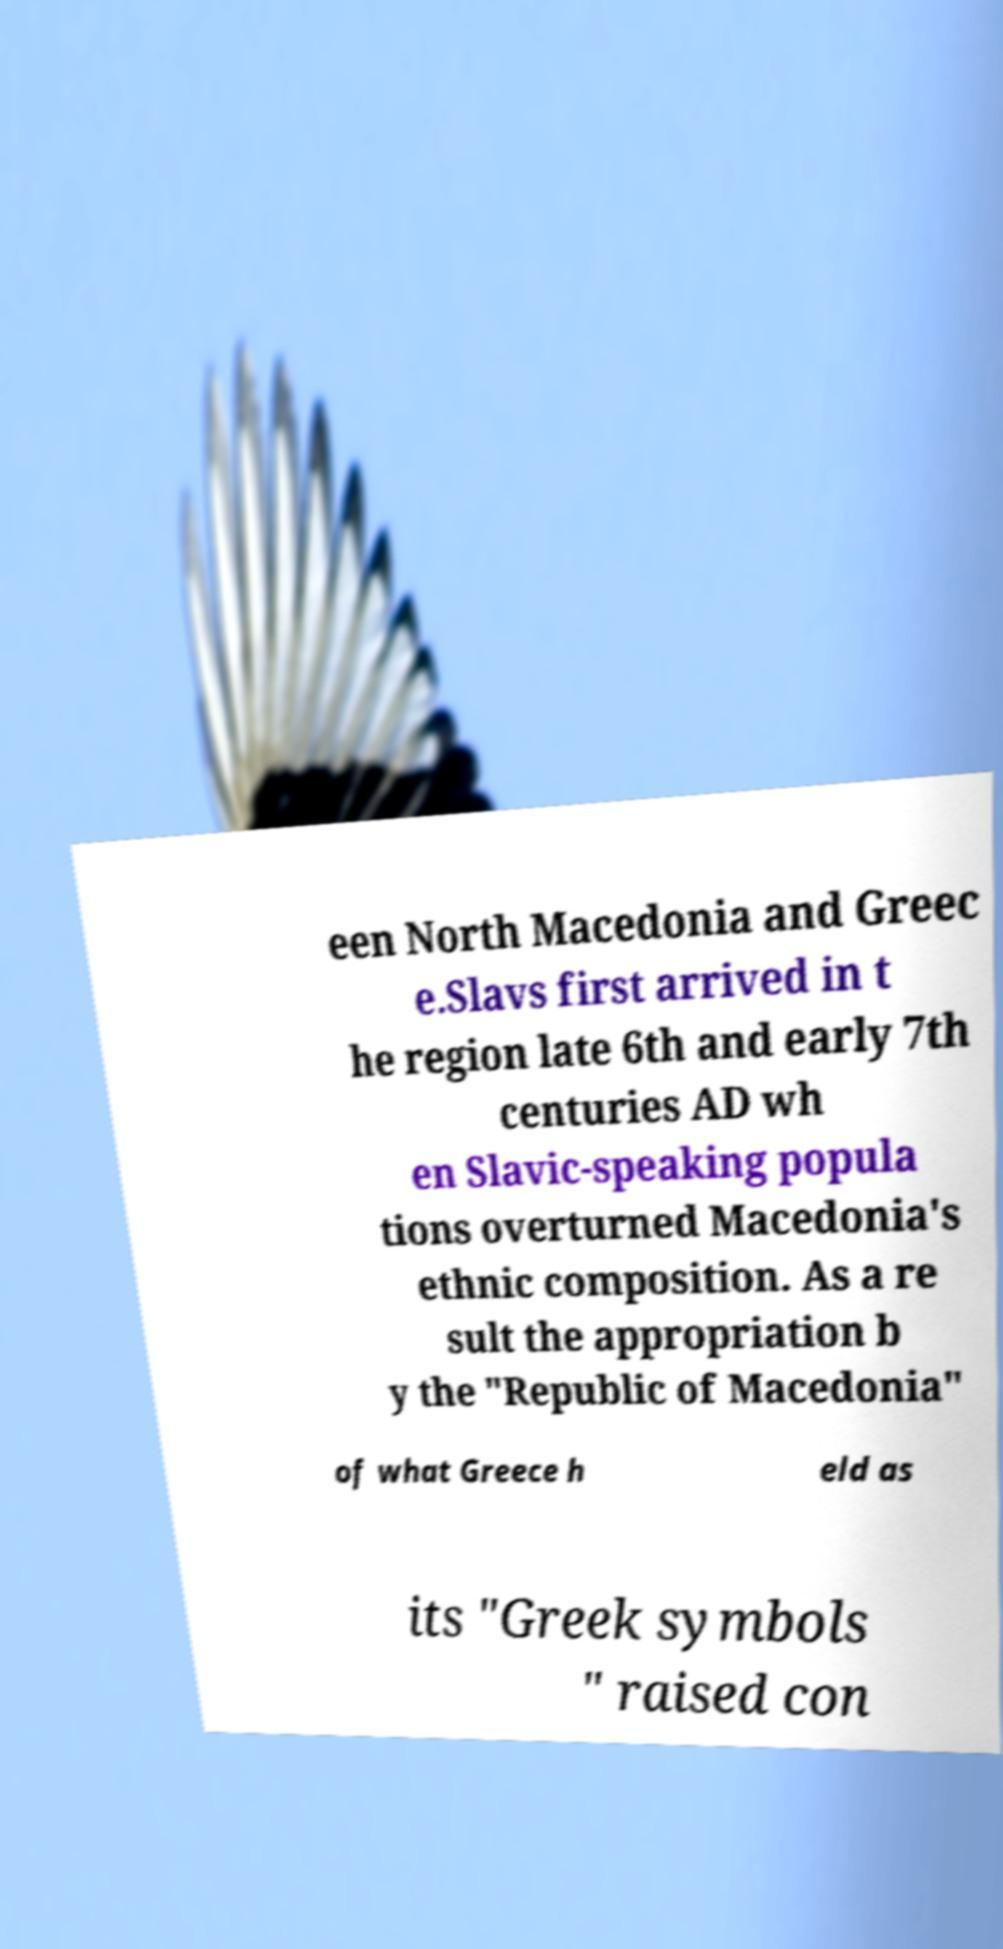I need the written content from this picture converted into text. Can you do that? een North Macedonia and Greec e.Slavs first arrived in t he region late 6th and early 7th centuries AD wh en Slavic-speaking popula tions overturned Macedonia's ethnic composition. As a re sult the appropriation b y the "Republic of Macedonia" of what Greece h eld as its "Greek symbols " raised con 